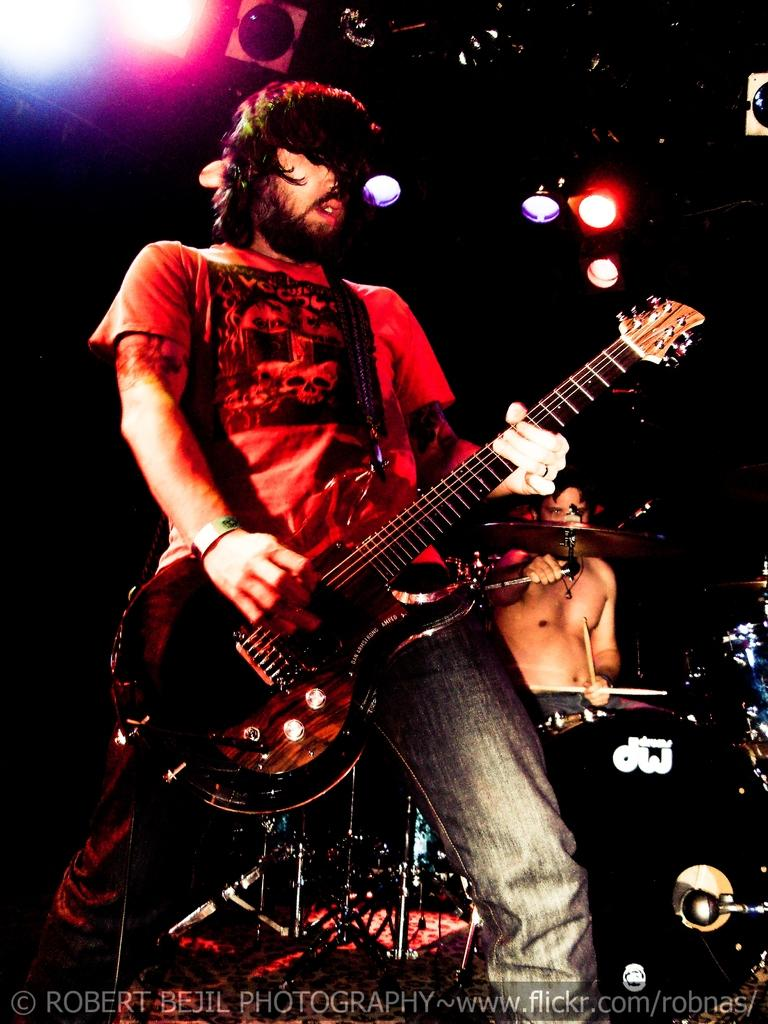What is the man in the image doing? The man is playing a guitar in the image. Who else is performing in the image? There is another person playing drums in the image. What can be seen in the background or surrounding the performers? There are colorful lights visible in the image. What type of reaction can be seen from the audience in the image? There is no audience present in the image, so it is not possible to determine any reactions. 